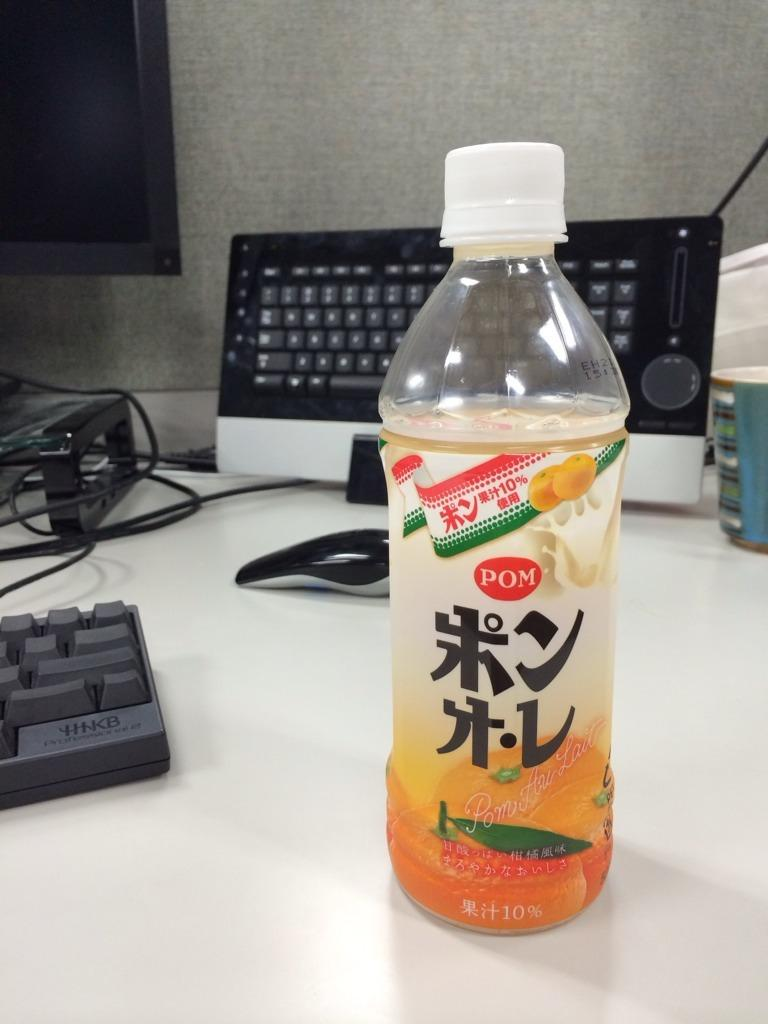What is on the table in the image? There is a juice bottle on the table. What is located behind the juice bottle? There is a keyboard and a mouse behind the juice bottle. What type of apparatus is used for milking cows in the image? There is no apparatus for milking cows present in the image. What kind of toys can be seen on the table in the image? There are no toys visible in the image; it features a juice bottle, a keyboard, and a mouse. 